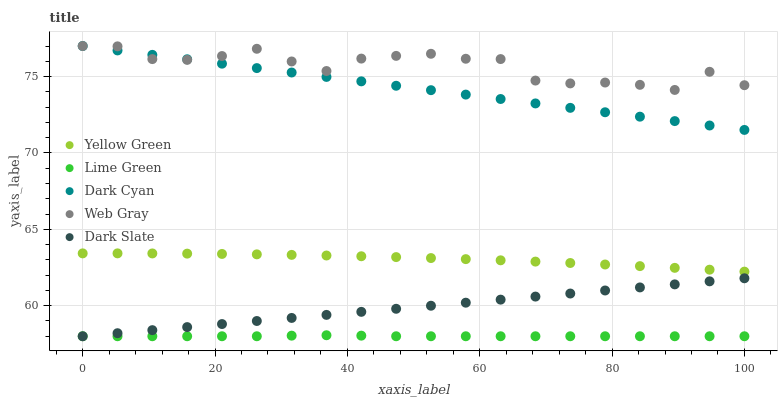Does Lime Green have the minimum area under the curve?
Answer yes or no. Yes. Does Web Gray have the maximum area under the curve?
Answer yes or no. Yes. Does Dark Slate have the minimum area under the curve?
Answer yes or no. No. Does Dark Slate have the maximum area under the curve?
Answer yes or no. No. Is Dark Slate the smoothest?
Answer yes or no. Yes. Is Web Gray the roughest?
Answer yes or no. Yes. Is Web Gray the smoothest?
Answer yes or no. No. Is Dark Slate the roughest?
Answer yes or no. No. Does Dark Slate have the lowest value?
Answer yes or no. Yes. Does Web Gray have the lowest value?
Answer yes or no. No. Does Web Gray have the highest value?
Answer yes or no. Yes. Does Dark Slate have the highest value?
Answer yes or no. No. Is Lime Green less than Yellow Green?
Answer yes or no. Yes. Is Web Gray greater than Lime Green?
Answer yes or no. Yes. Does Lime Green intersect Dark Slate?
Answer yes or no. Yes. Is Lime Green less than Dark Slate?
Answer yes or no. No. Is Lime Green greater than Dark Slate?
Answer yes or no. No. Does Lime Green intersect Yellow Green?
Answer yes or no. No. 